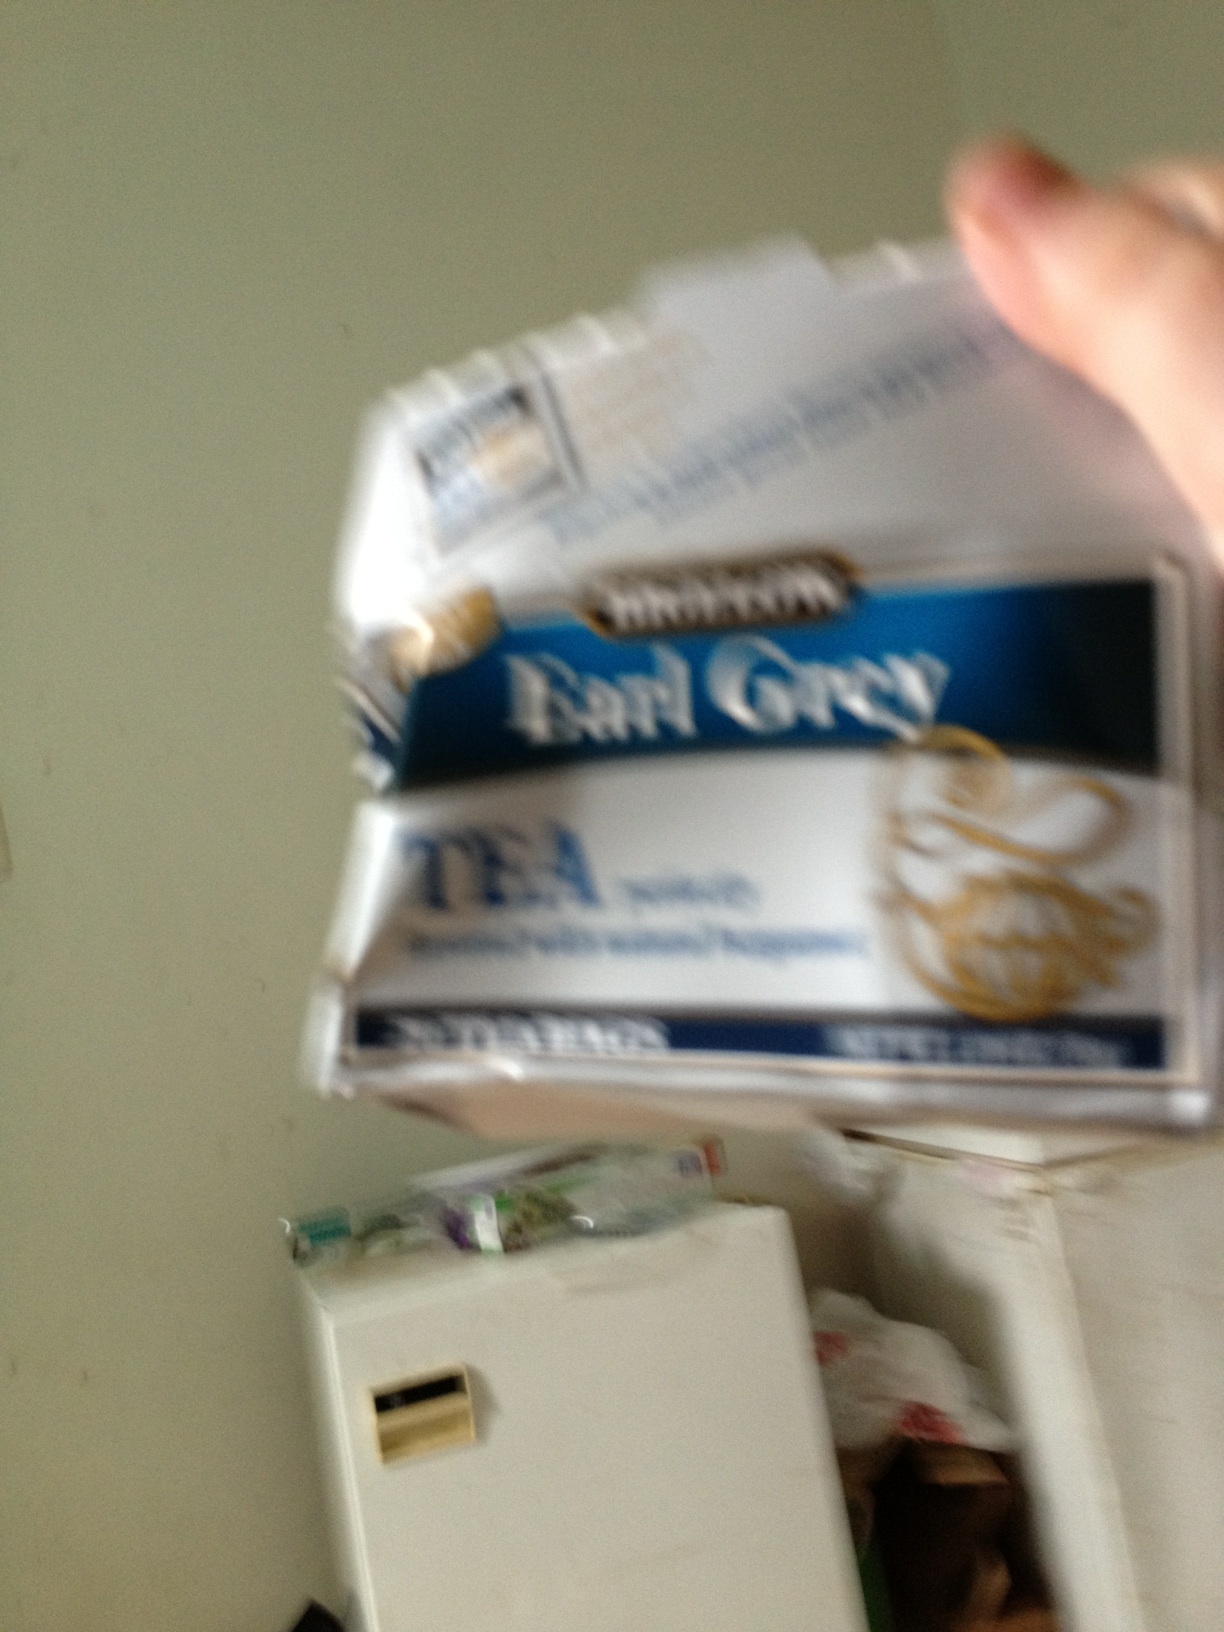What kind of tea is this? from Vizwiz earl grey 